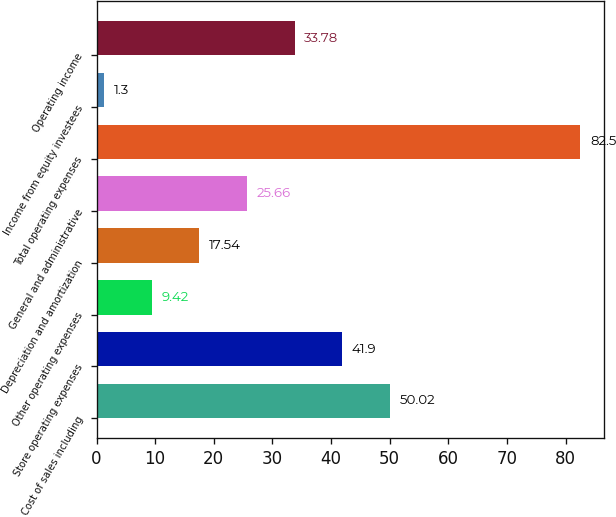<chart> <loc_0><loc_0><loc_500><loc_500><bar_chart><fcel>Cost of sales including<fcel>Store operating expenses<fcel>Other operating expenses<fcel>Depreciation and amortization<fcel>General and administrative<fcel>Total operating expenses<fcel>Income from equity investees<fcel>Operating income<nl><fcel>50.02<fcel>41.9<fcel>9.42<fcel>17.54<fcel>25.66<fcel>82.5<fcel>1.3<fcel>33.78<nl></chart> 